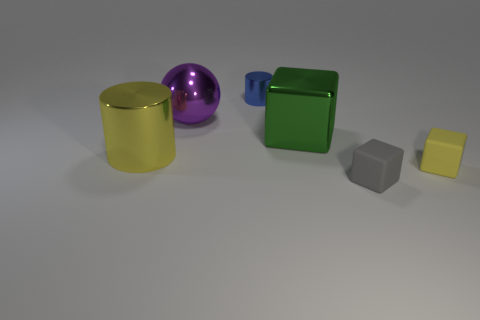Are there any blue cylinders behind the yellow matte block? yes 